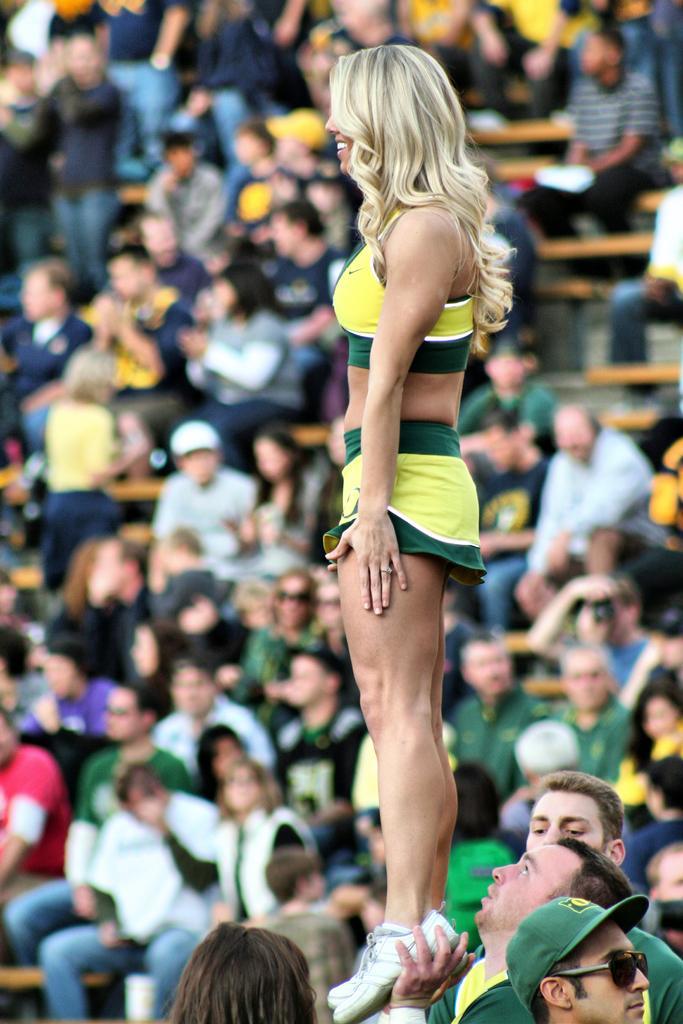Could you give a brief overview of what you see in this image? In this image there are people in the foreground. One person is lifting another person. There are many people sitting in the background. 